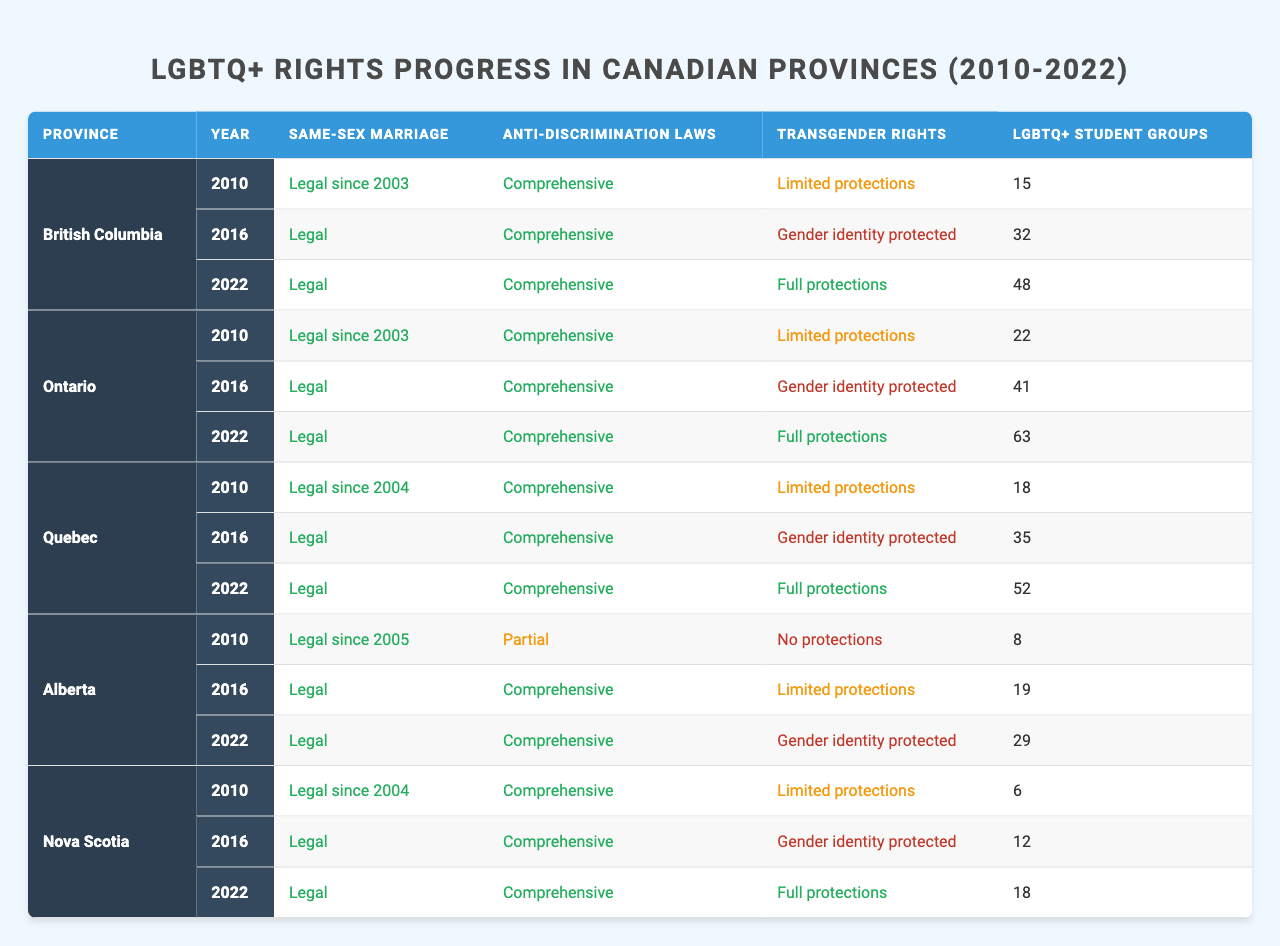What was the status of same-sex marriage in Alberta in 2010? According to the table, Alberta had same-sex marriage legal since 2005 in the year 2010. Therefore, the status was "Legal since 2005."
Answer: Legal since 2005 How many LGBTQ+ student groups were there in Ontario in 2022? Referring to the table, Ontario had 63 LGBTQ+ student groups listed for the year 2022.
Answer: 63 What is the trend of LGBTQ+ student groups in British Columbia from 2010 to 2022? In British Columbia, the number of LGBTQ+ student groups increased from 15 in 2010 to 48 in 2022. This indicates a positive trend in the growth of student groups.
Answer: Increasing Did Nova Scotia achieve full protections for transgender rights by 2022? Based on the table, by 2022, Nova Scotia had "Full protections" for transgender rights, meaning the answer is yes.
Answer: Yes Which province saw the highest number of LGBTQ+ student groups in 2016? Looking at the table, Ontario had the highest number of LGBTQ+ student groups in 2016 with 41 groups.
Answer: Ontario What is the average number of LGBTQ+ student groups across all provinces in 2016? The numbers of LGBTQ+ student groups in 2016 are 32 (BC), 41 (Ontario), 35 (Quebec), 19 (Alberta), and 12 (NS), totaling 139. Dividing by the 5 provinces gives an average of 139 / 5 = 27.8.
Answer: 27.8 Which province improved its anti-discrimination laws from partial to comprehensive between 2010 and 2016? From examining the table, Alberta improved its anti-discrimination laws from "Partial" in 2010 to "Comprehensive" in 2016.
Answer: Alberta In which year did Quebec achieve full protections for transgender rights? According to the table, Quebec achieved full protections for transgender rights by the year 2022.
Answer: 2022 How many provinces had "Limited protections" for transgender rights in 2010? Reviewing the table, both Alberta, Nova Scotia, Ontario, and Quebec had "Limited protections," totaling four provinces in 2010.
Answer: 4 If a province had comprehensive anti-discrimination laws, what can we infer about its transgender rights in 2022? Analyzing the table shows that for provinces with comprehensive anti-discrimination laws in 2022, they all had either "Gender identity protected" or "Full protections" for transgender rights, indicating progressive policies.
Answer: Progressive policies Which province had the largest improvement in LGBTQ+ student groups from 2010 to 2022? By calculating the difference: British Columbia increased from 15 to 48 (+33), Ontario from 22 to 63 (+41), Quebec from 18 to 52 (+34), Alberta from 8 to 29 (+21), and Nova Scotia from 6 to 18 (+12). Ontario had the largest increase of +41 groups.
Answer: Ontario 